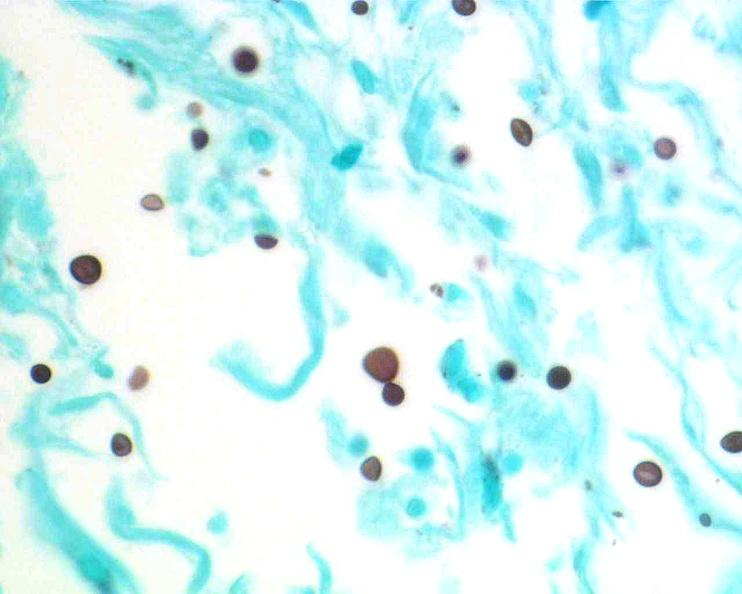what is present?
Answer the question using a single word or phrase. Nervous 